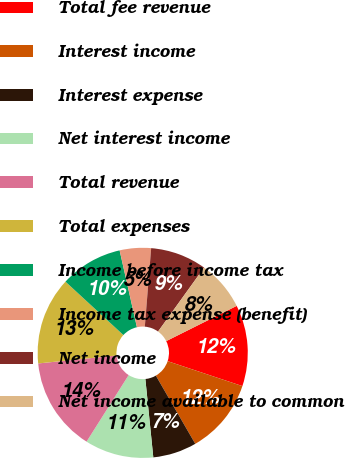Convert chart to OTSL. <chart><loc_0><loc_0><loc_500><loc_500><pie_chart><fcel>Total fee revenue<fcel>Interest income<fcel>Interest expense<fcel>Net interest income<fcel>Total revenue<fcel>Total expenses<fcel>Income before income tax<fcel>Income tax expense (benefit)<fcel>Net income<fcel>Net income available to common<nl><fcel>12.5%<fcel>11.54%<fcel>6.73%<fcel>10.58%<fcel>14.42%<fcel>13.46%<fcel>9.62%<fcel>4.81%<fcel>8.65%<fcel>7.69%<nl></chart> 